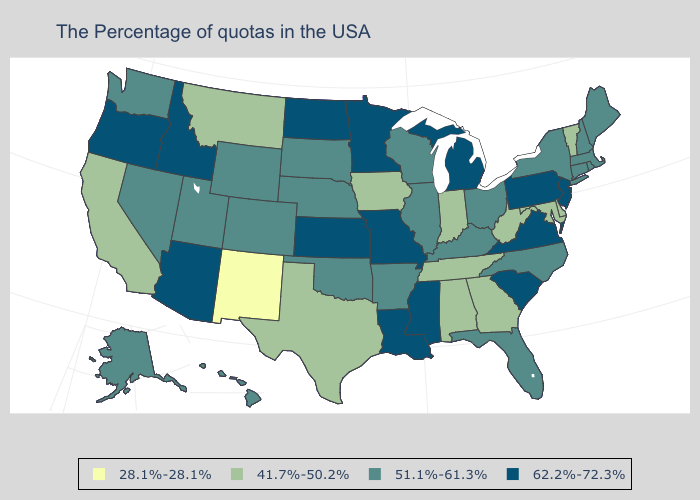What is the lowest value in the USA?
Be succinct. 28.1%-28.1%. Which states have the highest value in the USA?
Quick response, please. New Jersey, Pennsylvania, Virginia, South Carolina, Michigan, Mississippi, Louisiana, Missouri, Minnesota, Kansas, North Dakota, Arizona, Idaho, Oregon. Does the first symbol in the legend represent the smallest category?
Be succinct. Yes. Does the map have missing data?
Keep it brief. No. What is the highest value in states that border New Hampshire?
Give a very brief answer. 51.1%-61.3%. What is the highest value in states that border Michigan?
Keep it brief. 51.1%-61.3%. Which states have the lowest value in the MidWest?
Give a very brief answer. Indiana, Iowa. Which states have the lowest value in the USA?
Answer briefly. New Mexico. Does Rhode Island have the highest value in the USA?
Concise answer only. No. Among the states that border Indiana , which have the lowest value?
Write a very short answer. Ohio, Kentucky, Illinois. What is the value of Virginia?
Concise answer only. 62.2%-72.3%. Which states have the highest value in the USA?
Short answer required. New Jersey, Pennsylvania, Virginia, South Carolina, Michigan, Mississippi, Louisiana, Missouri, Minnesota, Kansas, North Dakota, Arizona, Idaho, Oregon. Among the states that border Alabama , which have the lowest value?
Concise answer only. Georgia, Tennessee. Which states have the lowest value in the USA?
Quick response, please. New Mexico. 